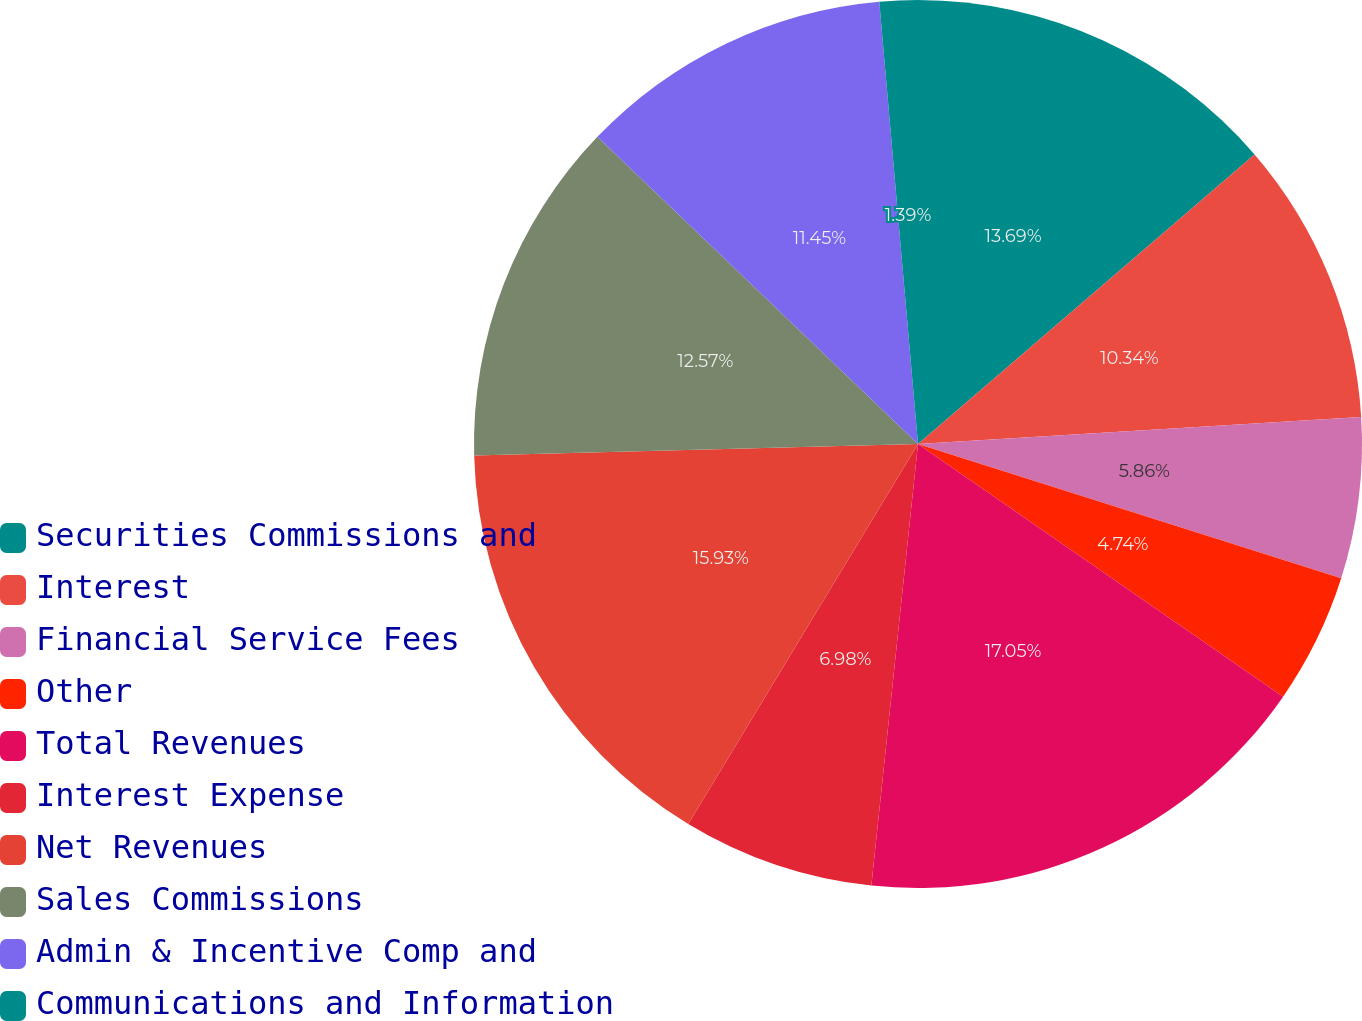<chart> <loc_0><loc_0><loc_500><loc_500><pie_chart><fcel>Securities Commissions and<fcel>Interest<fcel>Financial Service Fees<fcel>Other<fcel>Total Revenues<fcel>Interest Expense<fcel>Net Revenues<fcel>Sales Commissions<fcel>Admin & Incentive Comp and<fcel>Communications and Information<nl><fcel>13.69%<fcel>10.34%<fcel>5.86%<fcel>4.74%<fcel>17.04%<fcel>6.98%<fcel>15.93%<fcel>12.57%<fcel>11.45%<fcel>1.39%<nl></chart> 